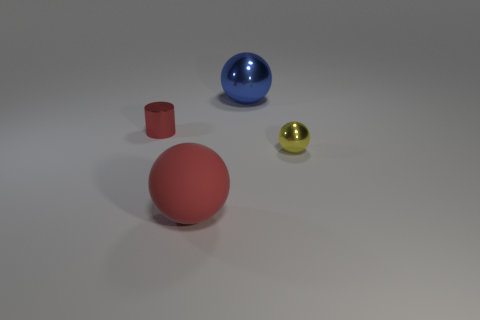What number of red rubber balls are in front of the matte object?
Your answer should be very brief. 0. Is the sphere that is on the right side of the large blue metallic sphere made of the same material as the cylinder?
Provide a succinct answer. Yes. What color is the other small shiny thing that is the same shape as the blue object?
Offer a terse response. Yellow. The large metallic object has what shape?
Give a very brief answer. Sphere. How many things are either large metal spheres or big red matte balls?
Your answer should be compact. 2. Does the tiny thing that is left of the large blue thing have the same color as the big thing in front of the tiny cylinder?
Give a very brief answer. Yes. How many other things are the same shape as the rubber thing?
Keep it short and to the point. 2. Are there any small yellow balls?
Ensure brevity in your answer.  Yes. What number of objects are either red cylinders or red rubber balls that are left of the large blue sphere?
Provide a short and direct response. 2. Does the blue metallic ball behind the shiny cylinder have the same size as the yellow metallic ball?
Offer a very short reply. No. 